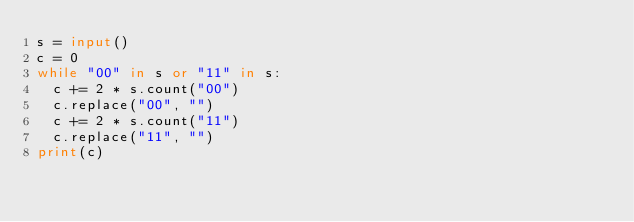Convert code to text. <code><loc_0><loc_0><loc_500><loc_500><_Python_>s = input()
c = 0
while "00" in s or "11" in s:
  c += 2 * s.count("00")
  c.replace("00", "")
  c += 2 * s.count("11")
  c.replace("11", "")
print(c)</code> 